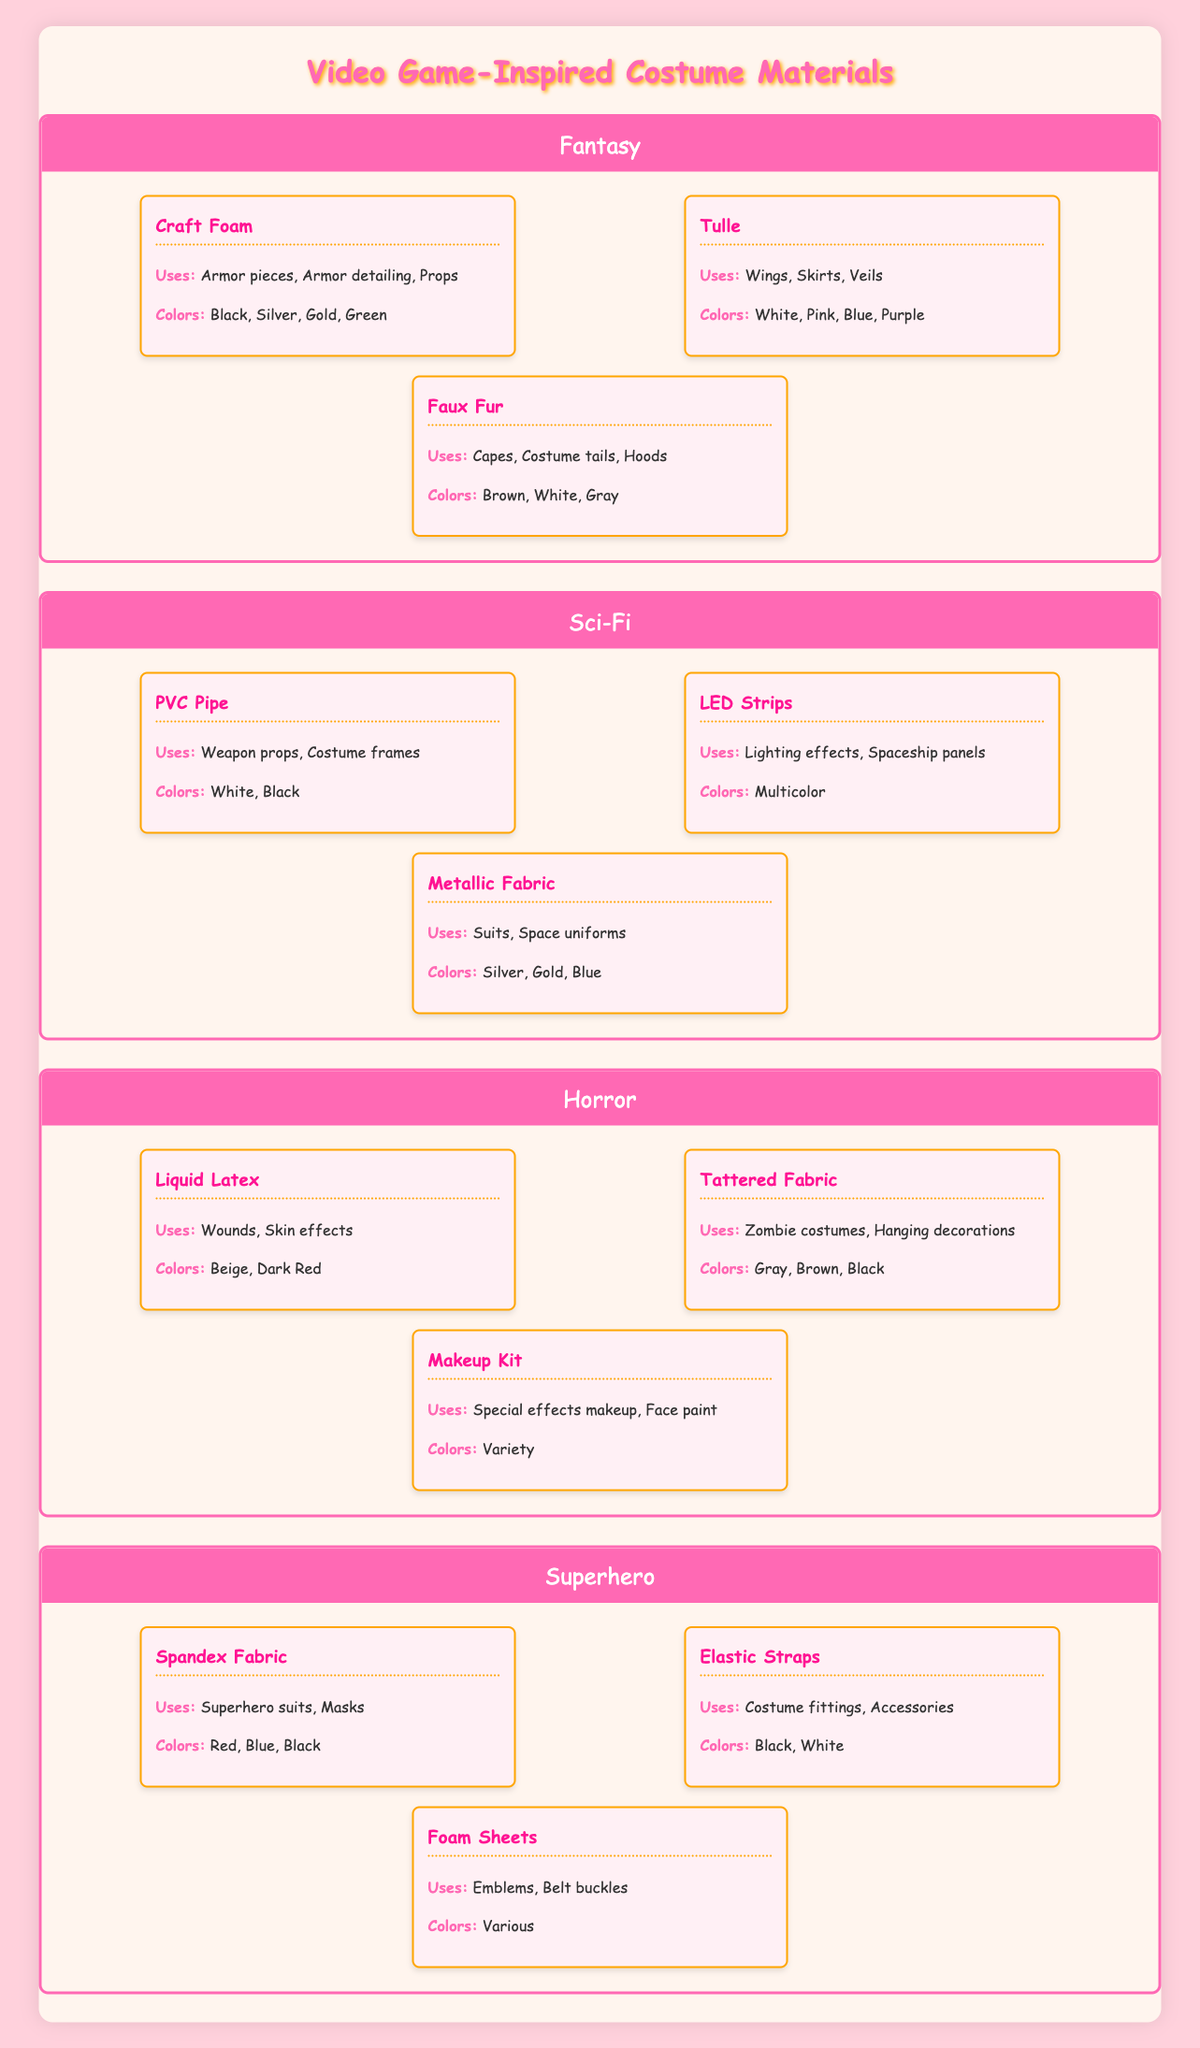What materials can be used for creating armor pieces in a Fantasy-themed costume? The materials listed under the Fantasy category that can be used for armor pieces are Craft Foam. The uses for Craft Foam include armor pieces, armor detailing, and props.
Answer: Craft Foam How many total colors are available for materials in the Superhero category? In the Superhero category, the colors available are Red, Blue, Black for Spandex Fabric; Black, White for Elastic Straps; and Various for Foam Sheets. Counting them gives us: 3 (Spandex) + 2 (Elastic) + 1 (Foam) = 6 distinct colors.
Answer: 6 Is there a material under the Horror category that can be used for wounds? The table indicates that Liquid Latex, listed under the Horror category, can be used for wounds. Since it is specifically mentioned among its uses, the answer is yes.
Answer: Yes What unique use does Tulle have in Fantasy costumes? Tulle is used for wings, skirts, and veils in Fantasy costumes. This can be found directly in the list of uses provided for Tulle under the Fantasy category.
Answer: Wings, Skirts, Veils How many materials in the Sci-Fi category can be used for weapon props? In the Sci-Fi category, the material listed for weapon props is PVC Pipe. Checking the materials section under Sci-Fi shows only PVC Pipe mentioned for this use, indicating that there is 1 material.
Answer: 1 Is Faux Fur available in Green color? The colors associated with Faux Fur in the Fantasy category are Brown, White, and Gray. Green is not listed among the colors for Faux Fur, thus the answer is no.
Answer: No Which theme has the widest variety of uses listed for a single material? Reviewing the materials, Liquid Latex under Horror has two uses: wounds and skin effects. In contrast, Craft Foam and Liquid Latex have multiple uses with their respective counts. However, in Fantasy, Craft Foam is used for three distinct purposes: armor pieces, armor detailing, and props, making it the material with the widest variety of uses listed.
Answer: Fantasy (Craft Foam) 